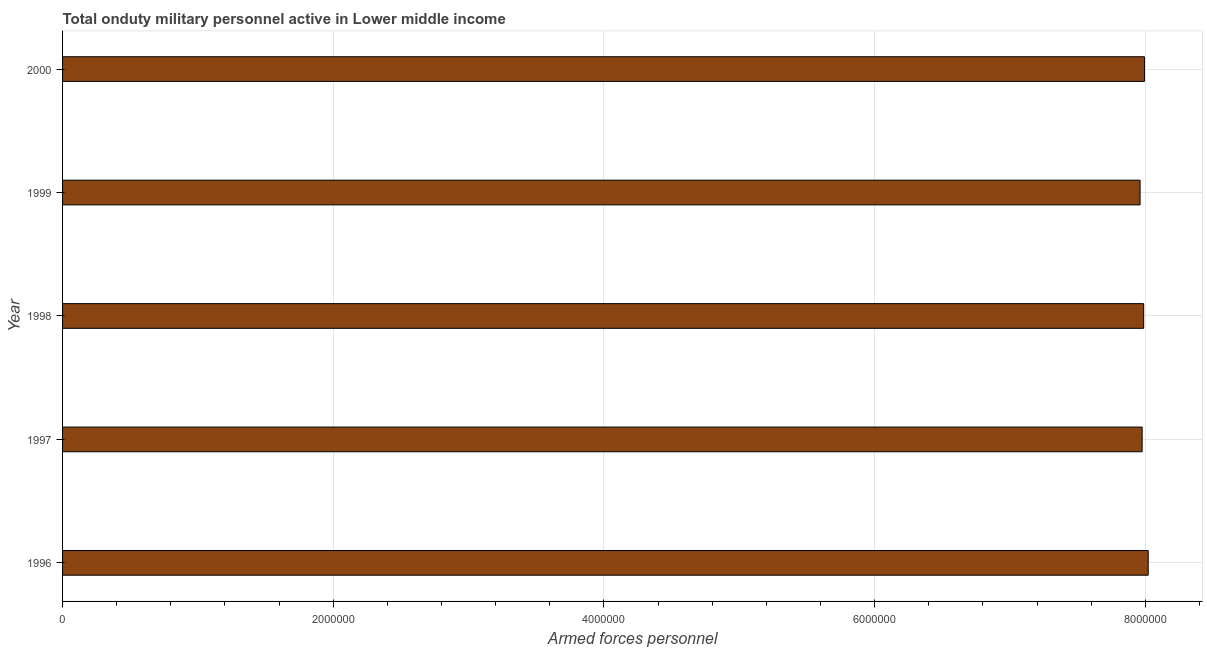Does the graph contain grids?
Your response must be concise. Yes. What is the title of the graph?
Offer a very short reply. Total onduty military personnel active in Lower middle income. What is the label or title of the X-axis?
Provide a short and direct response. Armed forces personnel. What is the label or title of the Y-axis?
Keep it short and to the point. Year. What is the number of armed forces personnel in 1998?
Provide a succinct answer. 7.99e+06. Across all years, what is the maximum number of armed forces personnel?
Your response must be concise. 8.02e+06. Across all years, what is the minimum number of armed forces personnel?
Offer a terse response. 7.96e+06. In which year was the number of armed forces personnel maximum?
Provide a succinct answer. 1996. What is the sum of the number of armed forces personnel?
Provide a short and direct response. 3.99e+07. What is the difference between the number of armed forces personnel in 1998 and 1999?
Ensure brevity in your answer.  2.64e+04. What is the average number of armed forces personnel per year?
Your response must be concise. 7.99e+06. What is the median number of armed forces personnel?
Provide a short and direct response. 7.99e+06. In how many years, is the number of armed forces personnel greater than 5600000 ?
Your response must be concise. 5. Is the number of armed forces personnel in 1996 less than that in 1999?
Offer a terse response. No. Is the difference between the number of armed forces personnel in 1996 and 2000 greater than the difference between any two years?
Your answer should be compact. No. What is the difference between the highest and the second highest number of armed forces personnel?
Your answer should be compact. 2.78e+04. What is the difference between the highest and the lowest number of armed forces personnel?
Offer a terse response. 6.01e+04. In how many years, is the number of armed forces personnel greater than the average number of armed forces personnel taken over all years?
Your answer should be very brief. 2. Are the values on the major ticks of X-axis written in scientific E-notation?
Your response must be concise. No. What is the Armed forces personnel of 1996?
Ensure brevity in your answer.  8.02e+06. What is the Armed forces personnel of 1997?
Provide a short and direct response. 7.98e+06. What is the Armed forces personnel in 1998?
Your answer should be compact. 7.99e+06. What is the Armed forces personnel in 1999?
Offer a very short reply. 7.96e+06. What is the Armed forces personnel of 2000?
Ensure brevity in your answer.  7.99e+06. What is the difference between the Armed forces personnel in 1996 and 1997?
Give a very brief answer. 4.48e+04. What is the difference between the Armed forces personnel in 1996 and 1998?
Offer a very short reply. 3.36e+04. What is the difference between the Armed forces personnel in 1996 and 1999?
Offer a very short reply. 6.01e+04. What is the difference between the Armed forces personnel in 1996 and 2000?
Give a very brief answer. 2.78e+04. What is the difference between the Armed forces personnel in 1997 and 1998?
Give a very brief answer. -1.12e+04. What is the difference between the Armed forces personnel in 1997 and 1999?
Give a very brief answer. 1.53e+04. What is the difference between the Armed forces personnel in 1997 and 2000?
Provide a succinct answer. -1.71e+04. What is the difference between the Armed forces personnel in 1998 and 1999?
Your response must be concise. 2.64e+04. What is the difference between the Armed forces personnel in 1998 and 2000?
Provide a short and direct response. -5900. What is the difference between the Armed forces personnel in 1999 and 2000?
Offer a terse response. -3.24e+04. What is the ratio of the Armed forces personnel in 1996 to that in 1998?
Your answer should be very brief. 1. What is the ratio of the Armed forces personnel in 1996 to that in 1999?
Offer a very short reply. 1.01. What is the ratio of the Armed forces personnel in 1996 to that in 2000?
Offer a terse response. 1. What is the ratio of the Armed forces personnel in 1997 to that in 1998?
Provide a short and direct response. 1. What is the ratio of the Armed forces personnel in 1997 to that in 1999?
Make the answer very short. 1. What is the ratio of the Armed forces personnel in 1999 to that in 2000?
Give a very brief answer. 1. 